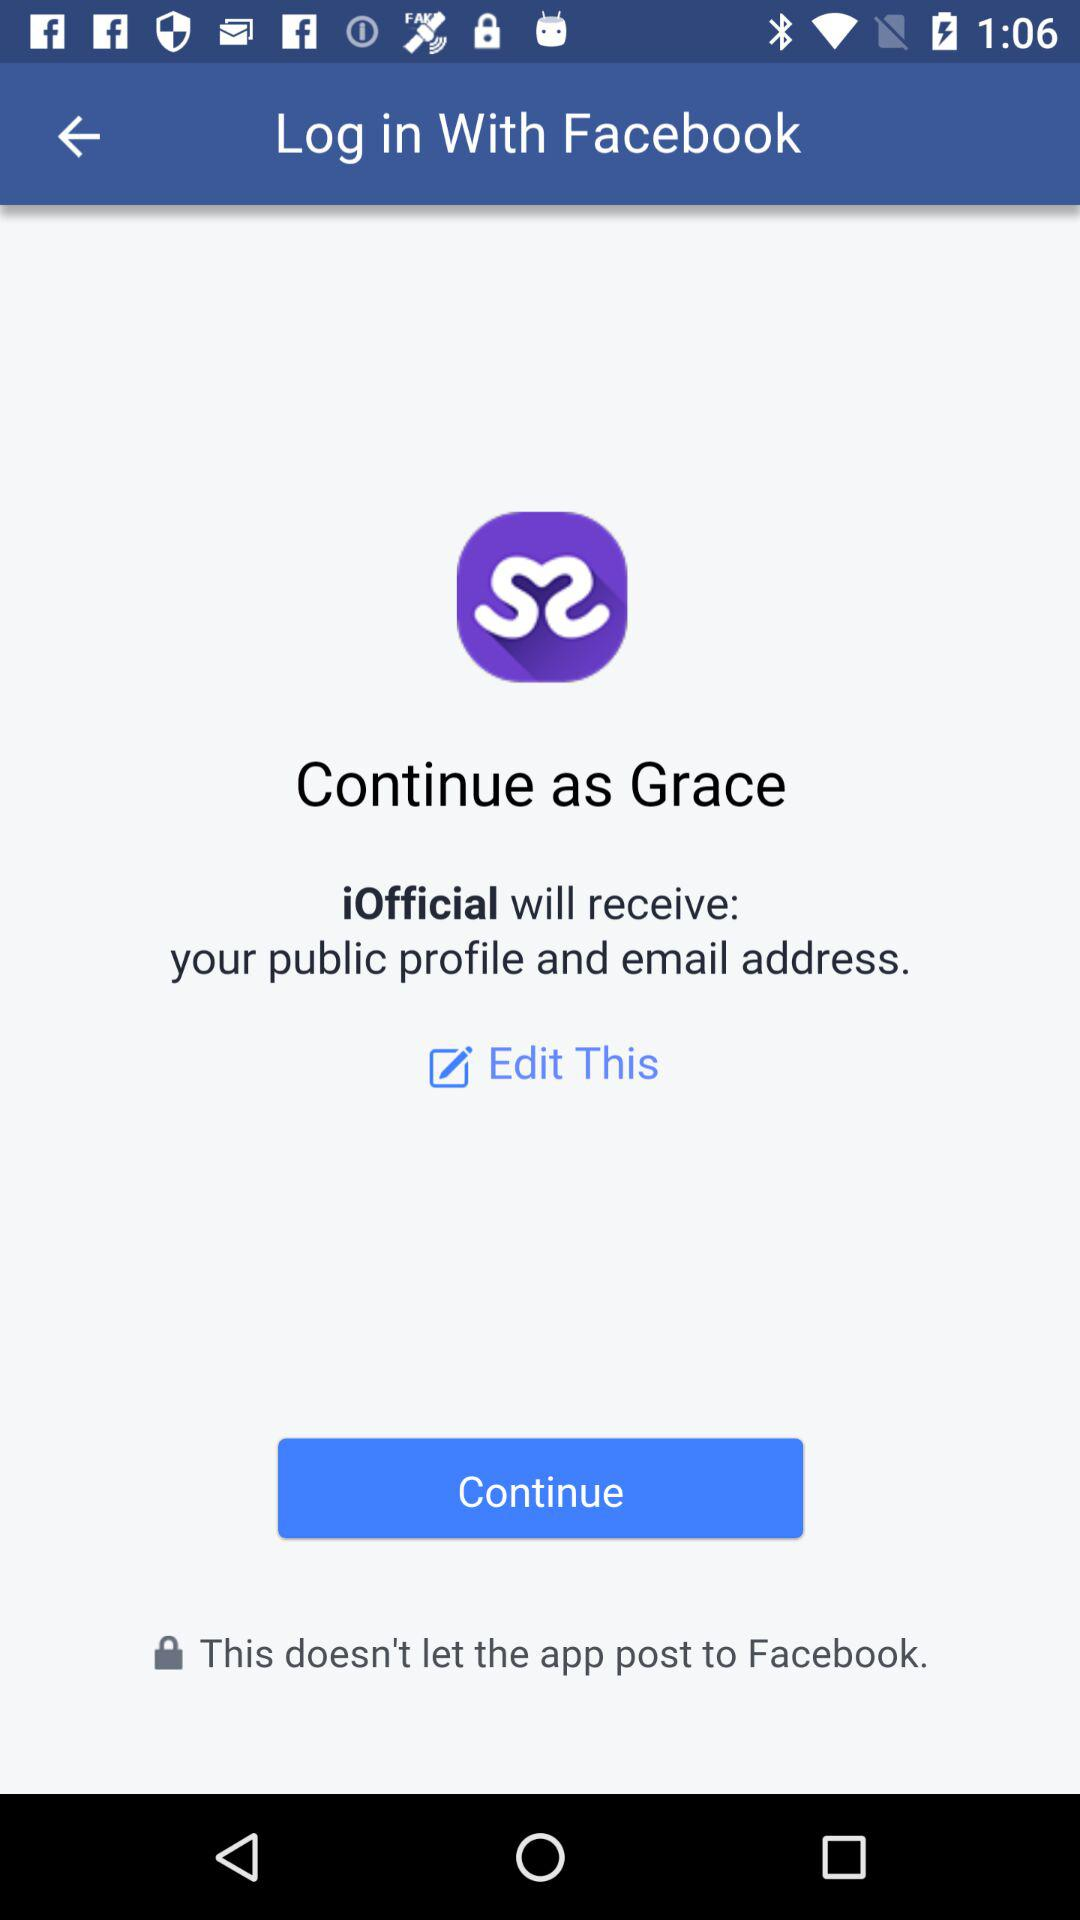What is the name of the user? The name of the user is Grace. 